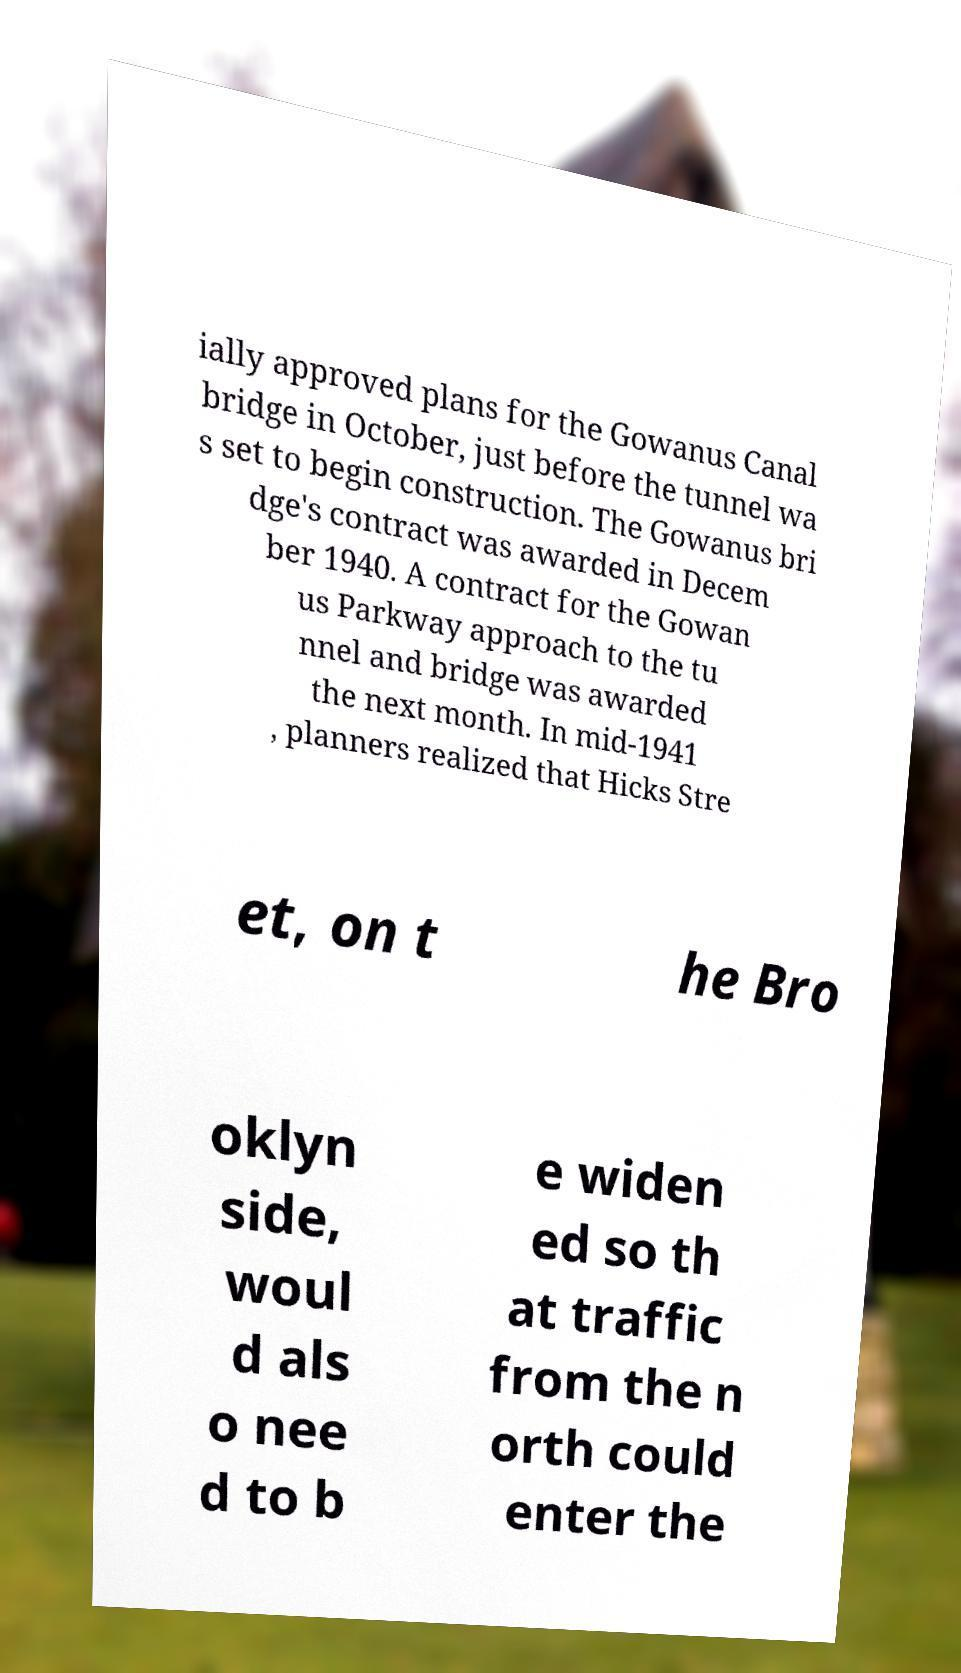For documentation purposes, I need the text within this image transcribed. Could you provide that? ially approved plans for the Gowanus Canal bridge in October, just before the tunnel wa s set to begin construction. The Gowanus bri dge's contract was awarded in Decem ber 1940. A contract for the Gowan us Parkway approach to the tu nnel and bridge was awarded the next month. In mid-1941 , planners realized that Hicks Stre et, on t he Bro oklyn side, woul d als o nee d to b e widen ed so th at traffic from the n orth could enter the 